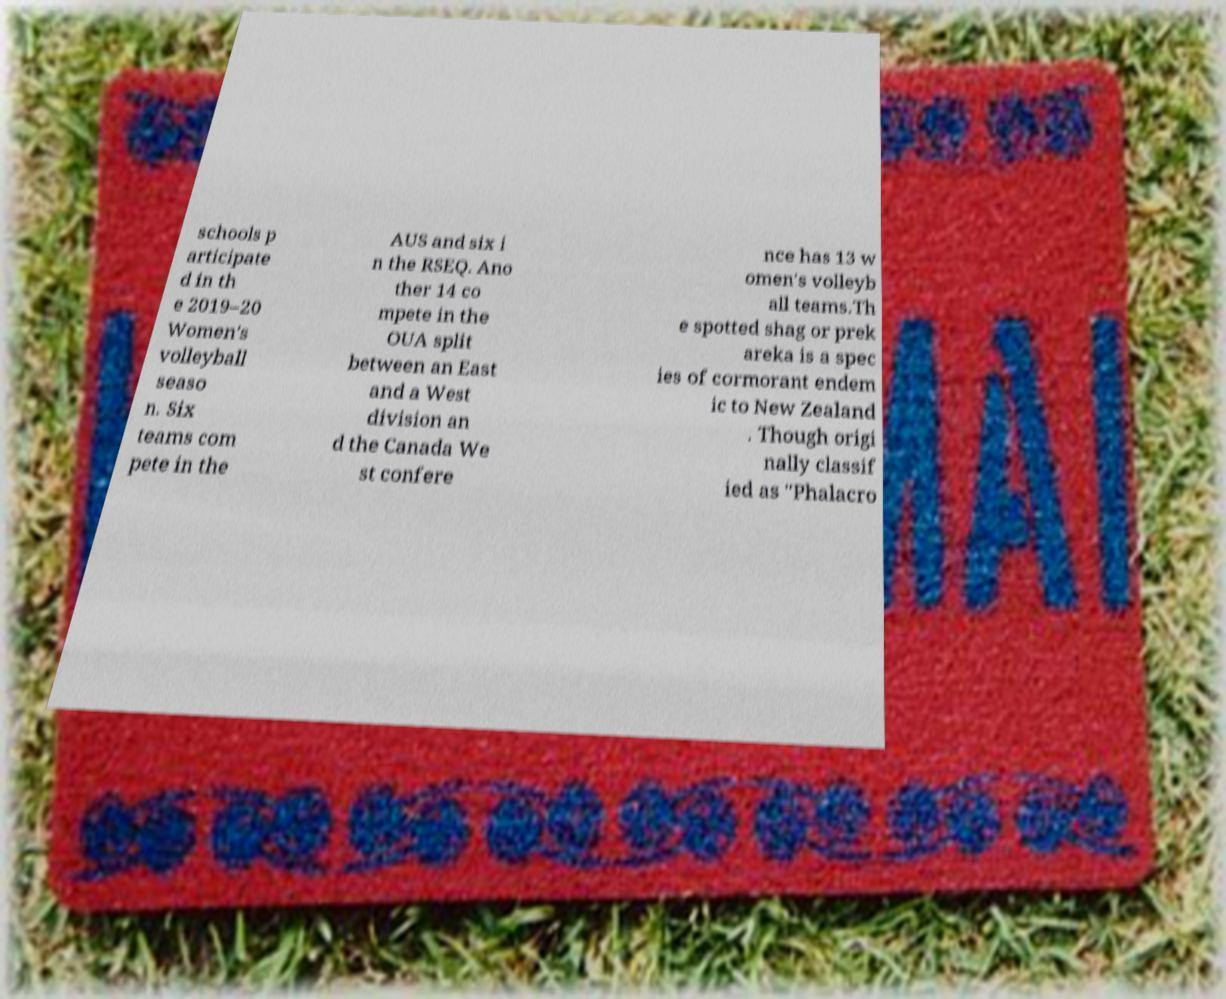Please read and relay the text visible in this image. What does it say? schools p articipate d in th e 2019–20 Women's volleyball seaso n. Six teams com pete in the AUS and six i n the RSEQ. Ano ther 14 co mpete in the OUA split between an East and a West division an d the Canada We st confere nce has 13 w omen's volleyb all teams.Th e spotted shag or prek areka is a spec ies of cormorant endem ic to New Zealand . Though origi nally classif ied as "Phalacro 